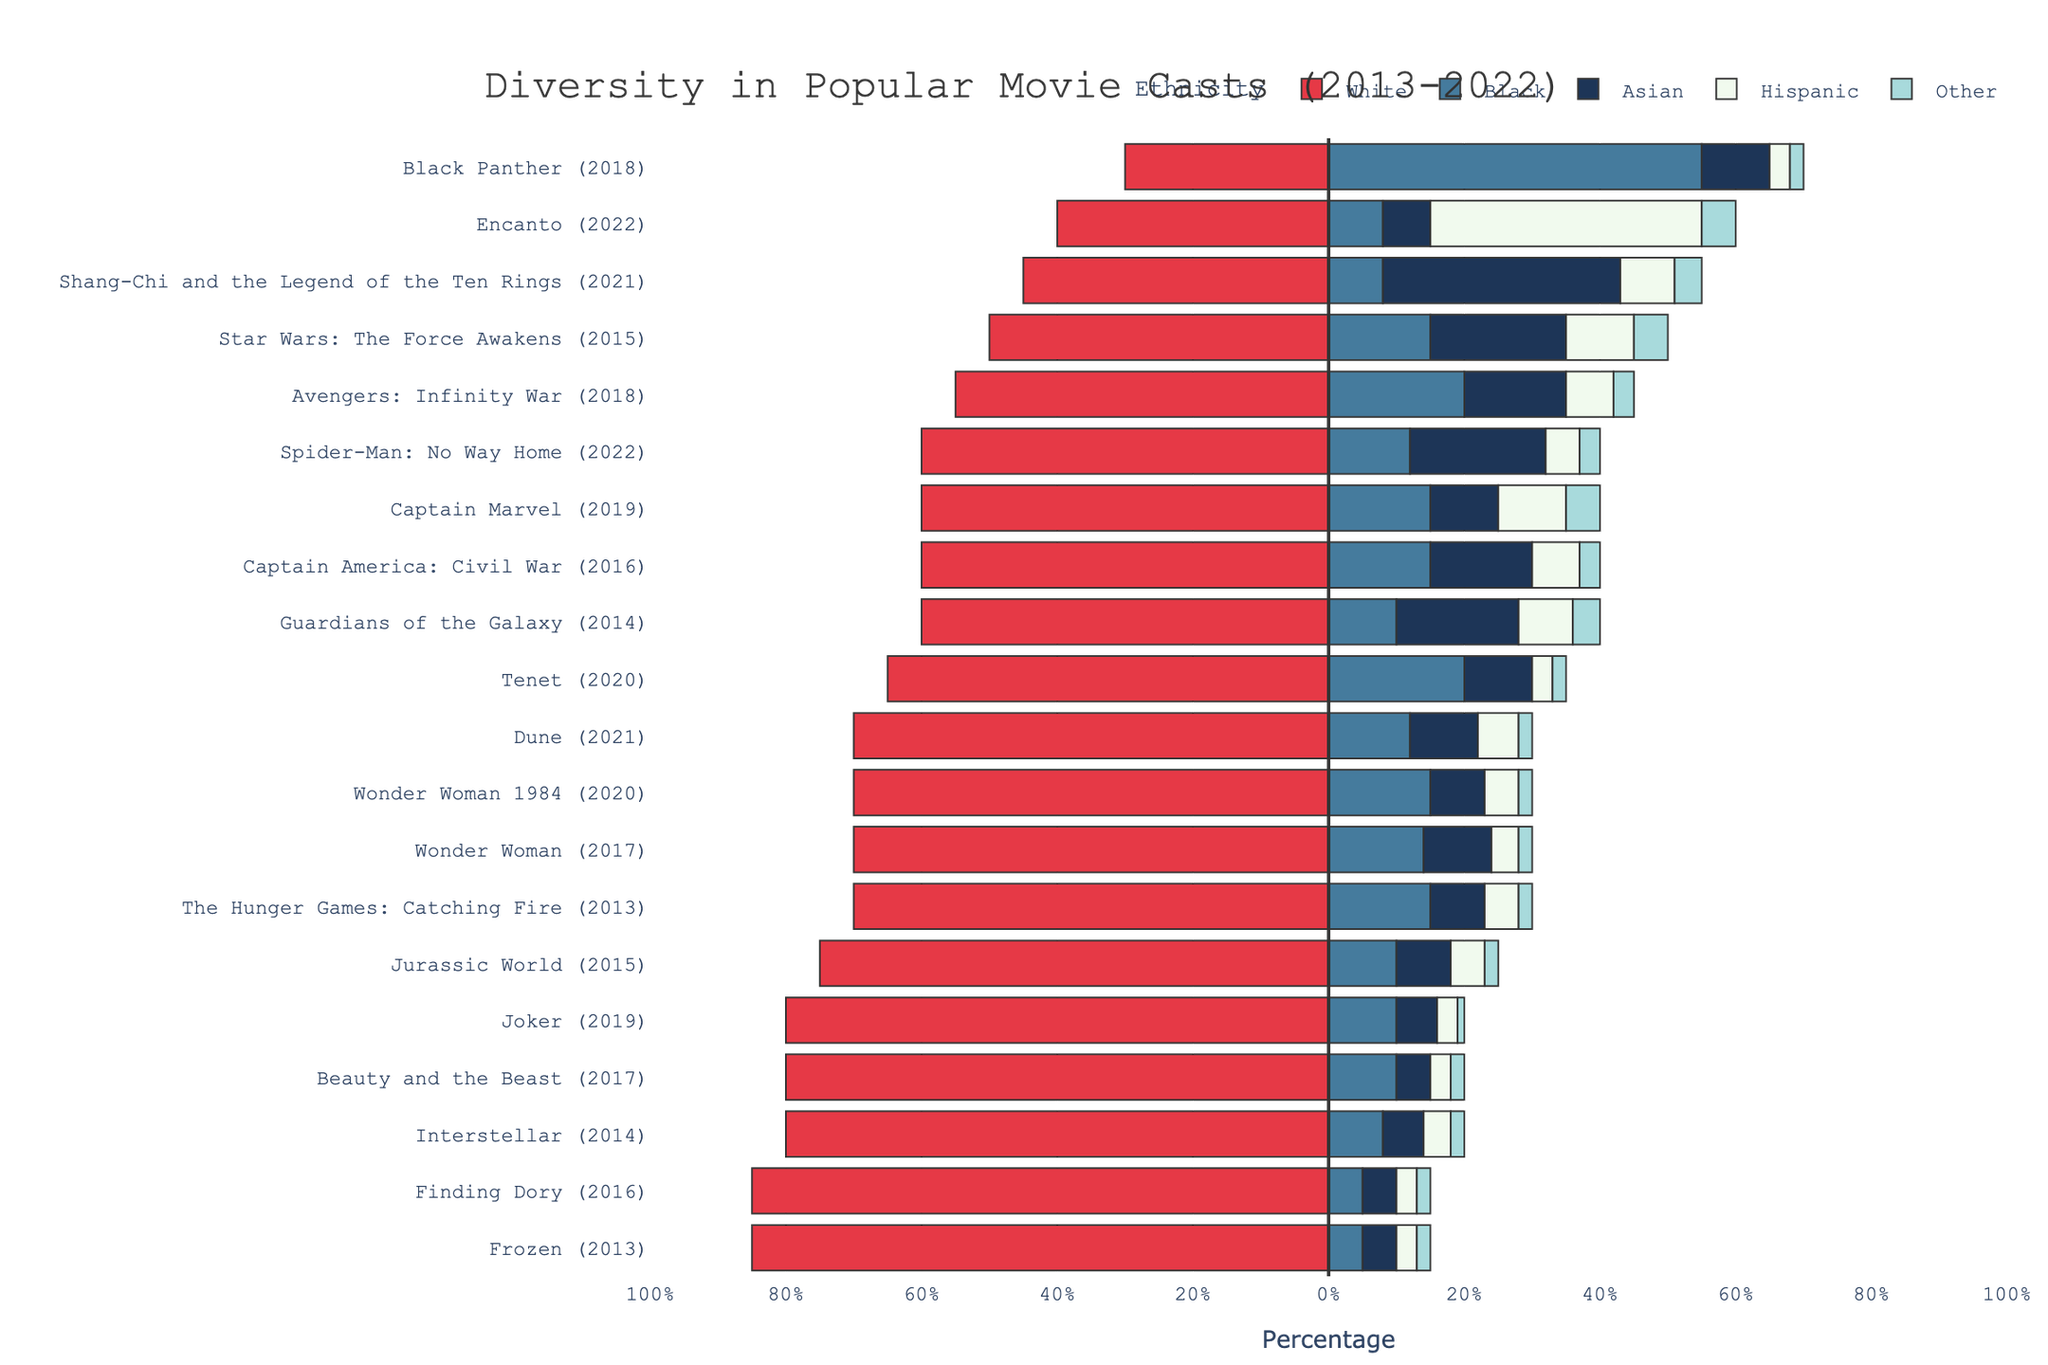Which movie has the most diverse cast in terms of ethnicity distribution? To assess the diversity in terms of ethnicity distribution, we look for a movie with relatively even percentages across all ethnic groups. "Star Wars: The Force Awakens" (2015) appears to have a more balanced distribution (50% White, 15% Black, 20% Asian, 10% Hispanic, 5% Other).
Answer: Star Wars: The Force Awakens Which movie has the highest percentage of Black cast members? Reviewing each bar segment colored in blue representing the Black cast members, "Black Panther" (2018) stands out with the longest bar segment indicating 55% of its cast is Black.
Answer: Black Panther Which year had the highest percentage of movies with predominantly White casts? Examining each movie's representation of White cast members, the years 2013 and 2014 consistently show higher percentages of White casts across all movies, such as "Frozen," "Interstellar," "Guardians of the Galaxy," and "The Hunger Games: Catching Fire."
Answer: 2013 and 2014 Comparing "Finding Dory" and "Encanto," which movie has a higher percentage of Hispanic cast members? "Encanto" (2022) has 40% Hispanic cast members, significantly higher than "Finding Dory" (2016), which has only 3%.
Answer: Encanto Calculate the average percentage of White cast members in 2017 movies. Summing the percentages of White cast members in 2017 movies: "Wonder Woman" (70%), "Beauty and the Beast" (80%), the total is 150%. Since there are 2 movies, the average is 150% / 2 = 75%.
Answer: 75% Which movie features a higher percentage of Asian cast members, "Shang-Chi and the Legend of the Ten Rings" or "Spider-Man: No Way Home"? Comparing the Asian representation, "Shang-Chi and the Legend of the Ten Rings" has 35% while "Spider-Man: No Way Home" has 20%.
Answer: Shang-Chi and the Legend of the Ten Rings Which year's movies have the highest combined percentage of Hispanic cast members? Aggregating Hispanic cast percentages for each year, we find that 2015's movies ("Star Wars: The Force Awakens" with 10% and "Jurassic World" with 5%) sum to 15%. 2022's "Encanto" alone has 40%, making it the highest.
Answer: 2022 What is the total percentage of non-White cast members in "Avengers: Infinity War"? Adding up the percentages of Black (20%), Asian (15%), Hispanic (7%), and Other (3%) for "Avengers: Infinity War" totals to 45%.
Answer: 45% Which  year displayed a substantial increase in diversity compared to the previous year? Comparing year by year visually, 2018 shows a substantial increase in diversity with "Black Panther" (55% Black) and "Avengers: Infinity War" (balanced distribution), significantly different compared to predominantly White movies in 2017.
Answer: 2018 What is the range of White cast percentages across all movies? The minimum and maximum White percentages are 30% ("Black Panther") and 85% ("Frozen" and "Finding Dory"), respectively. The range is calculated as 85% - 30% = 55%.
Answer: 55% 